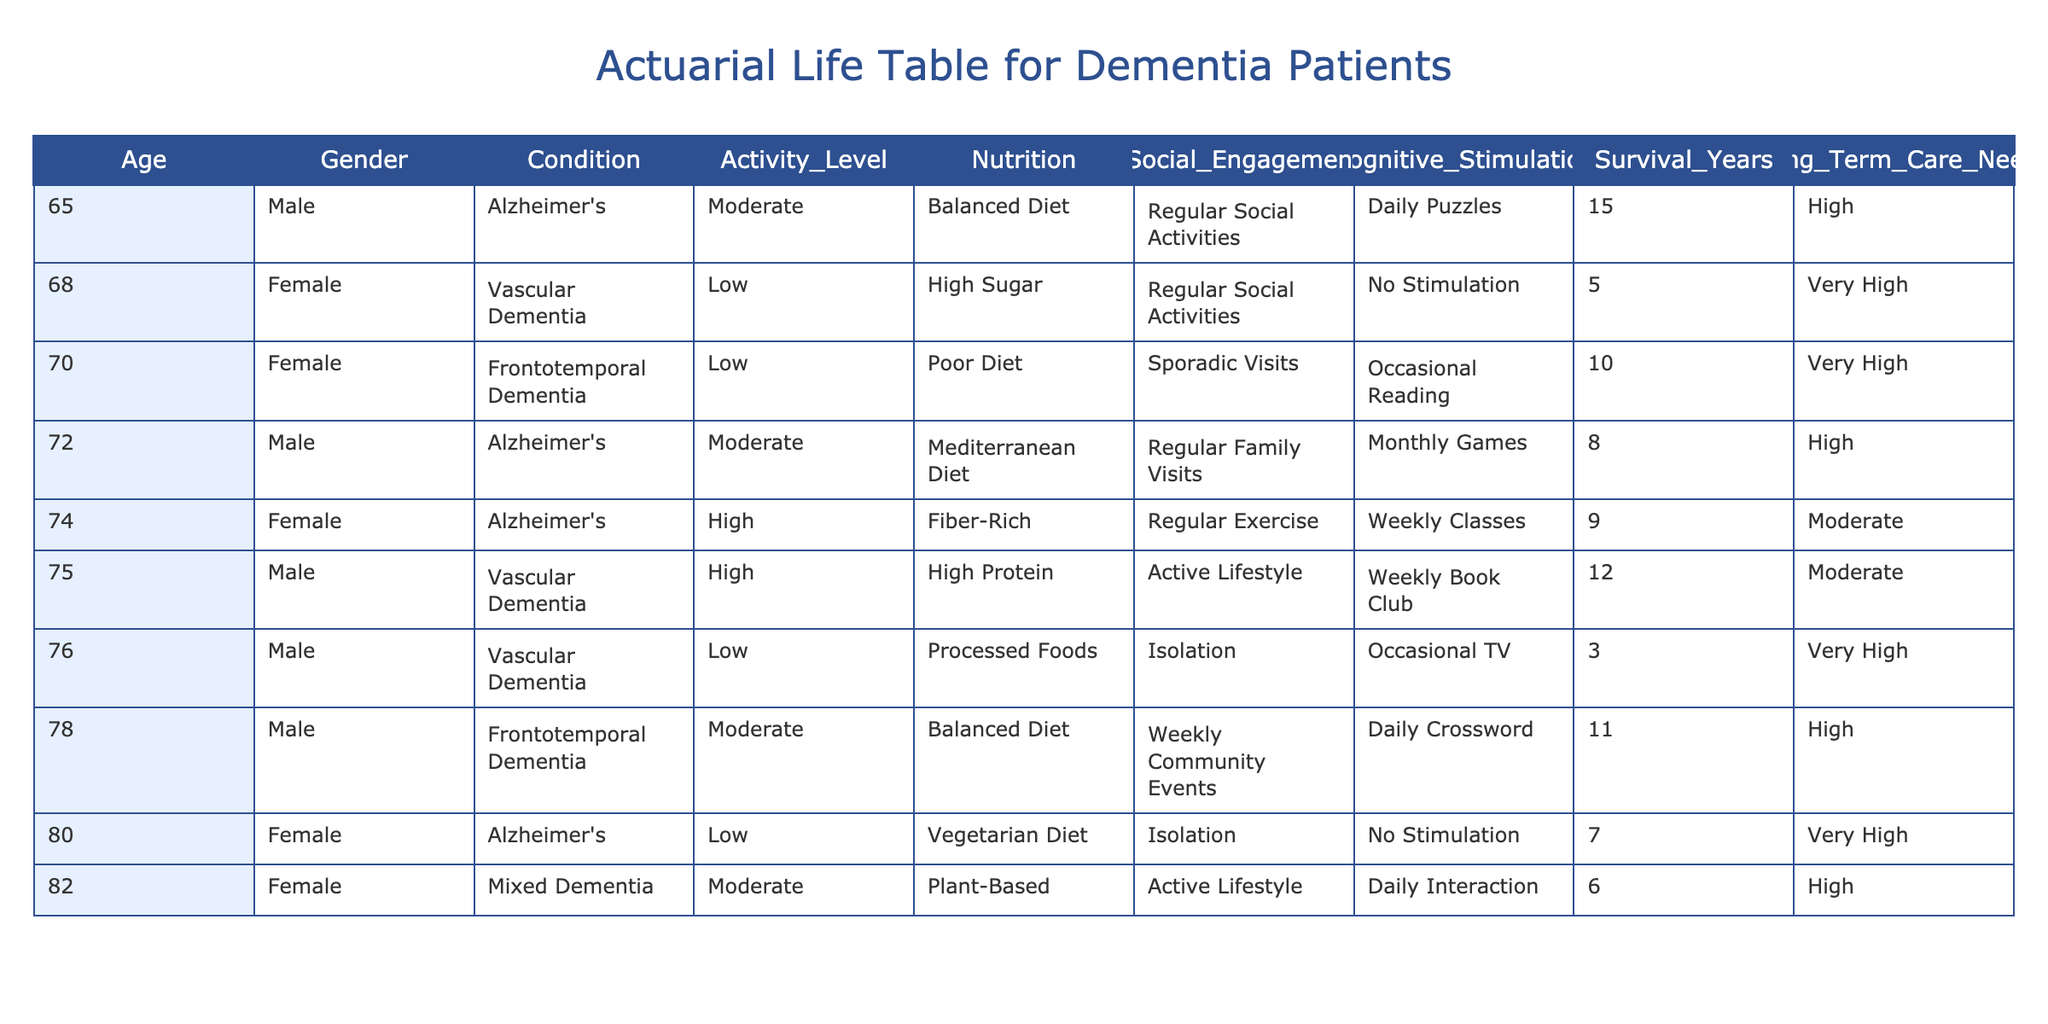What is the highest number of survival years listed in the table? The highest number of survival years can be found by scanning the 'Survival_Years' column for the maximum value. The highest value listed is 15, corresponding to a 65-year-old male with Alzheimer's.
Answer: 15 How many patients have a "Very High" long-term care need status? To find this, we can count the occurrences of "Very High" in the 'Long_Term_Care_Needs' column. There are 4 patients with "Very High" needs: one 70-year-old female, one 80-year-old female, one 68-year-old female, and one 76-year-old male.
Answer: 4 What is the average number of survival years for patients with a high activity level? First, identify patients with a 'High' activity level: one 75-year-old male with 12 survival years and one 74-year-old female with 9 survival years. Calculate the average: (12 + 9) / 2 = 10.5.
Answer: 10.5 Does the table indicate that dietary factors influence the long-term care needs of dementia patients? By examining the 'Nutrition' alongside 'Long_Term_Care_Needs', we can observe correlations. For example, those with balanced or high-protein diets generally have lower long-term care needs compared to those with poor or processed diets. Therefore, the statement can be considered true.
Answer: Yes What is the combined survival years of patients with "Frontotemporal Dementia"? To calculate, we find all patients with the condition of "Frontotemporal Dementia": there are two patients aged 70 (10 years) and 78 (11 years). Adding these gives us 10 + 11 = 21.
Answer: 21 Which gender has a higher average survival year across all patients? First, calculate the total survival years for males: (15 + 12 + 8 + 3 + 6) = 44 for 5 males. For females: (10 + 7 + 5 + 9) = 31 for 4 females. Then, calculate the averages: males have 44 / 5 = 8.8, while females have 31 / 4 = 7.75. Since 8.8 is greater than 7.75, males have higher average survival years.
Answer: Male How does social engagement correlate with long-term care needs among the lowest activity level patients? We can look at the patients with a 'Low' activity level and their social engagement. There are four patients here. Of these, one, who reports "Isolation," has "Very High" needs, two with "Sporadic Visits" have "Very High" needs, and one with "Regular Social Activities" has "Very High." This suggests that virtually all low-activity patients require high care regardless of social engagement, indicating limited correlation.
Answer: Limited correlation What percentage of patients have a balanced diet? The table has 8 patients, and there are 3 instances of a balanced diet: patients aged 65 (male), 78 (male), and 82 (female). To find the percentage: (3 / 8) * 100 = 37.5%.
Answer: 37.5% 